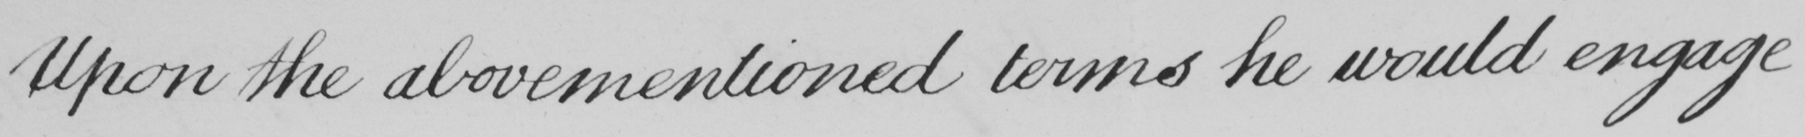Transcribe the text shown in this historical manuscript line. Upon the abovementioned terms he would engage 